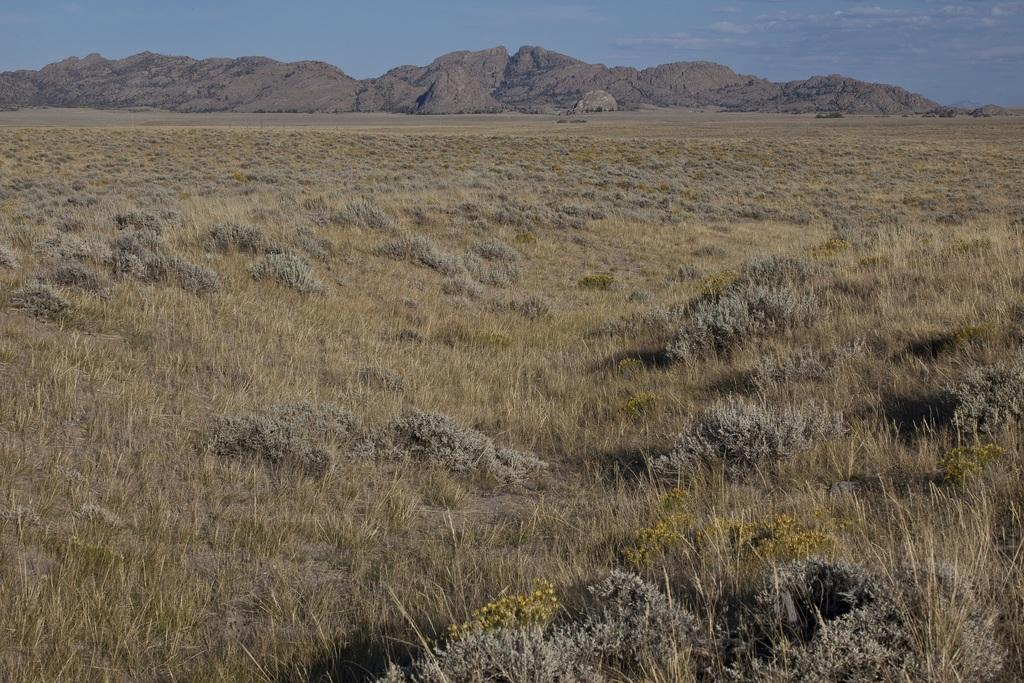What type of vegetation is present in the image? There is grass in the image. What can be seen in the distance in the image? There are hills visible in the background of the image. What is visible in the sky in the background of the image? There are clouds in the sky in the background of the image. How many babies are playing with the grass in the image? There are no babies present in the image; it only features grass, hills, and clouds. 